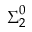Convert formula to latex. <formula><loc_0><loc_0><loc_500><loc_500>{ \Sigma } _ { 2 } ^ { 0 }</formula> 